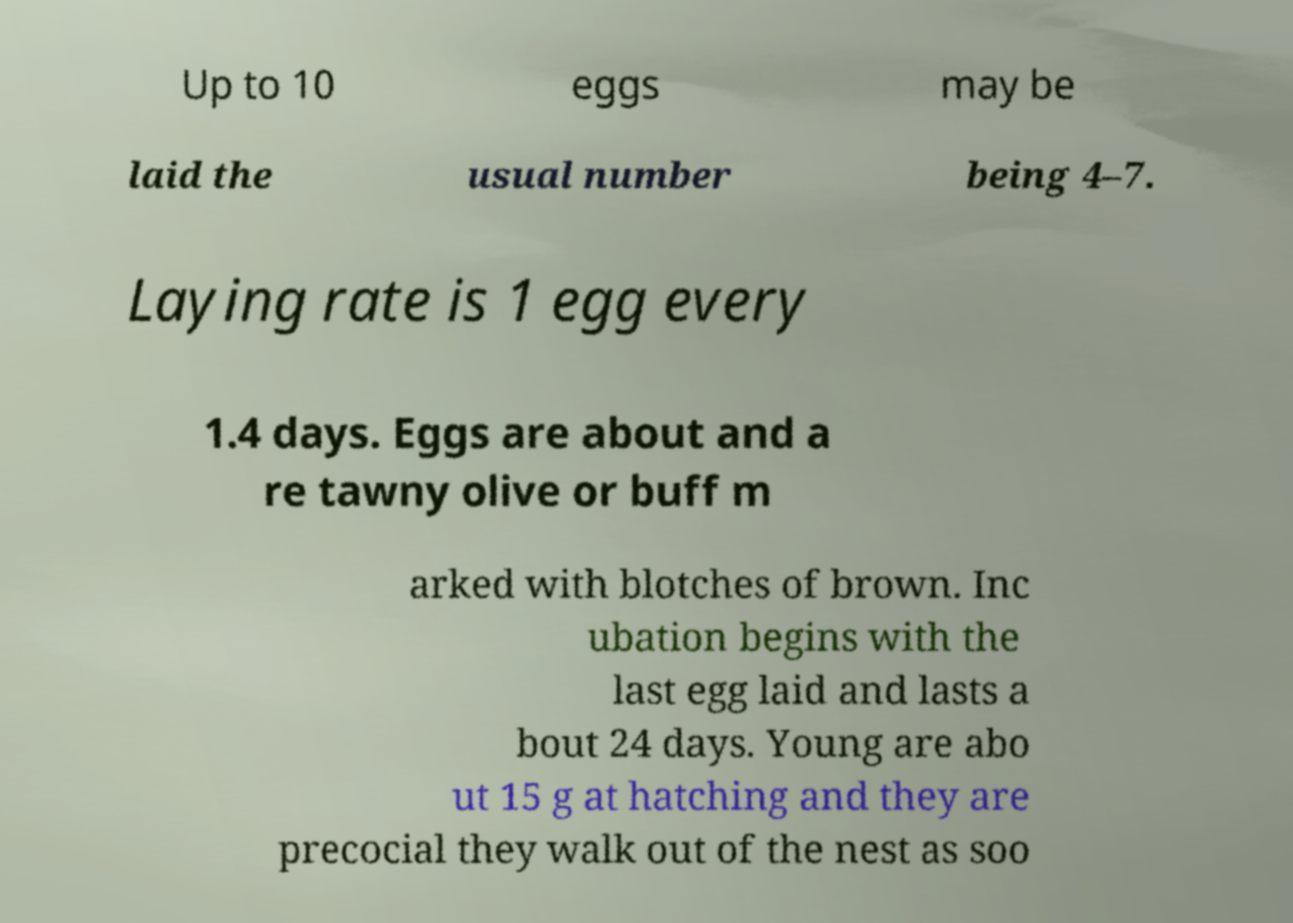Please read and relay the text visible in this image. What does it say? Up to 10 eggs may be laid the usual number being 4–7. Laying rate is 1 egg every 1.4 days. Eggs are about and a re tawny olive or buff m arked with blotches of brown. Inc ubation begins with the last egg laid and lasts a bout 24 days. Young are abo ut 15 g at hatching and they are precocial they walk out of the nest as soo 